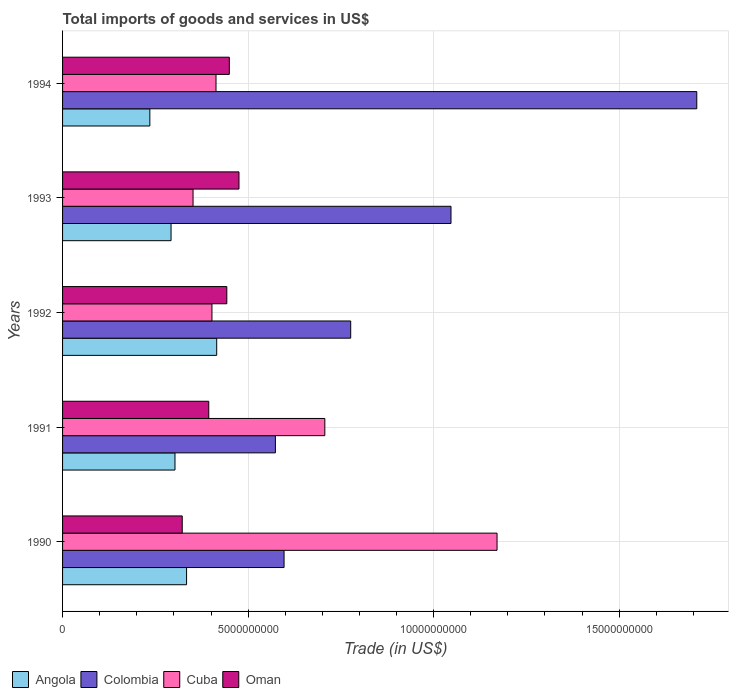How many groups of bars are there?
Provide a short and direct response. 5. Are the number of bars per tick equal to the number of legend labels?
Your answer should be compact. Yes. Are the number of bars on each tick of the Y-axis equal?
Offer a terse response. Yes. How many bars are there on the 2nd tick from the bottom?
Your answer should be very brief. 4. What is the total imports of goods and services in Cuba in 1992?
Make the answer very short. 4.03e+09. Across all years, what is the maximum total imports of goods and services in Angola?
Ensure brevity in your answer.  4.15e+09. Across all years, what is the minimum total imports of goods and services in Colombia?
Your response must be concise. 5.74e+09. In which year was the total imports of goods and services in Angola minimum?
Your response must be concise. 1994. What is the total total imports of goods and services in Cuba in the graph?
Provide a succinct answer. 3.05e+1. What is the difference between the total imports of goods and services in Oman in 1991 and that in 1993?
Provide a short and direct response. -8.14e+08. What is the difference between the total imports of goods and services in Colombia in 1994 and the total imports of goods and services in Angola in 1993?
Give a very brief answer. 1.42e+1. What is the average total imports of goods and services in Cuba per year?
Ensure brevity in your answer.  6.09e+09. In the year 1991, what is the difference between the total imports of goods and services in Cuba and total imports of goods and services in Oman?
Provide a succinct answer. 3.13e+09. What is the ratio of the total imports of goods and services in Cuba in 1991 to that in 1992?
Provide a succinct answer. 1.76. What is the difference between the highest and the second highest total imports of goods and services in Colombia?
Provide a succinct answer. 6.62e+09. What is the difference between the highest and the lowest total imports of goods and services in Angola?
Keep it short and to the point. 1.80e+09. In how many years, is the total imports of goods and services in Oman greater than the average total imports of goods and services in Oman taken over all years?
Your response must be concise. 3. Is it the case that in every year, the sum of the total imports of goods and services in Angola and total imports of goods and services in Colombia is greater than the sum of total imports of goods and services in Oman and total imports of goods and services in Cuba?
Your response must be concise. Yes. What does the 2nd bar from the top in 1992 represents?
Provide a succinct answer. Cuba. What does the 2nd bar from the bottom in 1994 represents?
Ensure brevity in your answer.  Colombia. How many bars are there?
Your answer should be compact. 20. Are all the bars in the graph horizontal?
Ensure brevity in your answer.  Yes. How many years are there in the graph?
Ensure brevity in your answer.  5. What is the difference between two consecutive major ticks on the X-axis?
Offer a very short reply. 5.00e+09. Are the values on the major ticks of X-axis written in scientific E-notation?
Offer a very short reply. No. Does the graph contain grids?
Offer a terse response. Yes. How many legend labels are there?
Your answer should be compact. 4. What is the title of the graph?
Your answer should be very brief. Total imports of goods and services in US$. What is the label or title of the X-axis?
Your response must be concise. Trade (in US$). What is the Trade (in US$) of Angola in 1990?
Ensure brevity in your answer.  3.34e+09. What is the Trade (in US$) in Colombia in 1990?
Provide a succinct answer. 5.97e+09. What is the Trade (in US$) in Cuba in 1990?
Give a very brief answer. 1.17e+1. What is the Trade (in US$) of Oman in 1990?
Ensure brevity in your answer.  3.22e+09. What is the Trade (in US$) of Angola in 1991?
Your answer should be very brief. 3.03e+09. What is the Trade (in US$) of Colombia in 1991?
Your answer should be compact. 5.74e+09. What is the Trade (in US$) in Cuba in 1991?
Ensure brevity in your answer.  7.07e+09. What is the Trade (in US$) in Oman in 1991?
Your answer should be compact. 3.94e+09. What is the Trade (in US$) in Angola in 1992?
Provide a succinct answer. 4.15e+09. What is the Trade (in US$) of Colombia in 1992?
Keep it short and to the point. 7.77e+09. What is the Trade (in US$) of Cuba in 1992?
Provide a succinct answer. 4.03e+09. What is the Trade (in US$) in Oman in 1992?
Your answer should be compact. 4.43e+09. What is the Trade (in US$) in Angola in 1993?
Your answer should be compact. 2.92e+09. What is the Trade (in US$) in Colombia in 1993?
Offer a terse response. 1.05e+1. What is the Trade (in US$) in Cuba in 1993?
Your answer should be very brief. 3.52e+09. What is the Trade (in US$) of Oman in 1993?
Offer a very short reply. 4.75e+09. What is the Trade (in US$) in Angola in 1994?
Offer a very short reply. 2.35e+09. What is the Trade (in US$) in Colombia in 1994?
Give a very brief answer. 1.71e+1. What is the Trade (in US$) of Cuba in 1994?
Make the answer very short. 4.14e+09. What is the Trade (in US$) of Oman in 1994?
Your answer should be very brief. 4.49e+09. Across all years, what is the maximum Trade (in US$) in Angola?
Your answer should be very brief. 4.15e+09. Across all years, what is the maximum Trade (in US$) in Colombia?
Your response must be concise. 1.71e+1. Across all years, what is the maximum Trade (in US$) of Cuba?
Make the answer very short. 1.17e+1. Across all years, what is the maximum Trade (in US$) in Oman?
Keep it short and to the point. 4.75e+09. Across all years, what is the minimum Trade (in US$) of Angola?
Make the answer very short. 2.35e+09. Across all years, what is the minimum Trade (in US$) of Colombia?
Give a very brief answer. 5.74e+09. Across all years, what is the minimum Trade (in US$) in Cuba?
Make the answer very short. 3.52e+09. Across all years, what is the minimum Trade (in US$) in Oman?
Provide a succinct answer. 3.22e+09. What is the total Trade (in US$) of Angola in the graph?
Offer a terse response. 1.58e+1. What is the total Trade (in US$) of Colombia in the graph?
Ensure brevity in your answer.  4.70e+1. What is the total Trade (in US$) in Cuba in the graph?
Your response must be concise. 3.05e+1. What is the total Trade (in US$) in Oman in the graph?
Offer a very short reply. 2.08e+1. What is the difference between the Trade (in US$) in Angola in 1990 and that in 1991?
Provide a short and direct response. 3.13e+08. What is the difference between the Trade (in US$) in Colombia in 1990 and that in 1991?
Ensure brevity in your answer.  2.33e+08. What is the difference between the Trade (in US$) of Cuba in 1990 and that in 1991?
Give a very brief answer. 4.64e+09. What is the difference between the Trade (in US$) of Oman in 1990 and that in 1991?
Provide a succinct answer. -7.15e+08. What is the difference between the Trade (in US$) of Angola in 1990 and that in 1992?
Your response must be concise. -8.12e+08. What is the difference between the Trade (in US$) in Colombia in 1990 and that in 1992?
Your response must be concise. -1.80e+09. What is the difference between the Trade (in US$) of Cuba in 1990 and that in 1992?
Your response must be concise. 7.68e+09. What is the difference between the Trade (in US$) of Oman in 1990 and that in 1992?
Give a very brief answer. -1.20e+09. What is the difference between the Trade (in US$) in Angola in 1990 and that in 1993?
Make the answer very short. 4.19e+08. What is the difference between the Trade (in US$) in Colombia in 1990 and that in 1993?
Your answer should be compact. -4.50e+09. What is the difference between the Trade (in US$) in Cuba in 1990 and that in 1993?
Give a very brief answer. 8.19e+09. What is the difference between the Trade (in US$) in Oman in 1990 and that in 1993?
Your response must be concise. -1.53e+09. What is the difference between the Trade (in US$) of Angola in 1990 and that in 1994?
Your answer should be very brief. 9.90e+08. What is the difference between the Trade (in US$) in Colombia in 1990 and that in 1994?
Give a very brief answer. -1.11e+1. What is the difference between the Trade (in US$) of Cuba in 1990 and that in 1994?
Your response must be concise. 7.57e+09. What is the difference between the Trade (in US$) in Oman in 1990 and that in 1994?
Ensure brevity in your answer.  -1.27e+09. What is the difference between the Trade (in US$) in Angola in 1991 and that in 1992?
Give a very brief answer. -1.12e+09. What is the difference between the Trade (in US$) in Colombia in 1991 and that in 1992?
Keep it short and to the point. -2.03e+09. What is the difference between the Trade (in US$) of Cuba in 1991 and that in 1992?
Keep it short and to the point. 3.04e+09. What is the difference between the Trade (in US$) of Oman in 1991 and that in 1992?
Make the answer very short. -4.86e+08. What is the difference between the Trade (in US$) of Angola in 1991 and that in 1993?
Provide a succinct answer. 1.06e+08. What is the difference between the Trade (in US$) of Colombia in 1991 and that in 1993?
Provide a short and direct response. -4.73e+09. What is the difference between the Trade (in US$) in Cuba in 1991 and that in 1993?
Ensure brevity in your answer.  3.55e+09. What is the difference between the Trade (in US$) in Oman in 1991 and that in 1993?
Ensure brevity in your answer.  -8.14e+08. What is the difference between the Trade (in US$) of Angola in 1991 and that in 1994?
Give a very brief answer. 6.78e+08. What is the difference between the Trade (in US$) in Colombia in 1991 and that in 1994?
Give a very brief answer. -1.14e+1. What is the difference between the Trade (in US$) of Cuba in 1991 and that in 1994?
Ensure brevity in your answer.  2.93e+09. What is the difference between the Trade (in US$) in Oman in 1991 and that in 1994?
Provide a short and direct response. -5.54e+08. What is the difference between the Trade (in US$) in Angola in 1992 and that in 1993?
Your response must be concise. 1.23e+09. What is the difference between the Trade (in US$) in Colombia in 1992 and that in 1993?
Offer a terse response. -2.70e+09. What is the difference between the Trade (in US$) of Cuba in 1992 and that in 1993?
Ensure brevity in your answer.  5.09e+08. What is the difference between the Trade (in US$) in Oman in 1992 and that in 1993?
Your answer should be compact. -3.28e+08. What is the difference between the Trade (in US$) of Angola in 1992 and that in 1994?
Your answer should be very brief. 1.80e+09. What is the difference between the Trade (in US$) in Colombia in 1992 and that in 1994?
Provide a succinct answer. -9.33e+09. What is the difference between the Trade (in US$) of Cuba in 1992 and that in 1994?
Your answer should be very brief. -1.09e+08. What is the difference between the Trade (in US$) in Oman in 1992 and that in 1994?
Your answer should be very brief. -6.76e+07. What is the difference between the Trade (in US$) of Angola in 1993 and that in 1994?
Provide a short and direct response. 5.72e+08. What is the difference between the Trade (in US$) in Colombia in 1993 and that in 1994?
Give a very brief answer. -6.62e+09. What is the difference between the Trade (in US$) in Cuba in 1993 and that in 1994?
Your response must be concise. -6.19e+08. What is the difference between the Trade (in US$) in Oman in 1993 and that in 1994?
Your response must be concise. 2.60e+08. What is the difference between the Trade (in US$) of Angola in 1990 and the Trade (in US$) of Colombia in 1991?
Your response must be concise. -2.39e+09. What is the difference between the Trade (in US$) in Angola in 1990 and the Trade (in US$) in Cuba in 1991?
Your answer should be very brief. -3.73e+09. What is the difference between the Trade (in US$) in Angola in 1990 and the Trade (in US$) in Oman in 1991?
Your answer should be very brief. -5.98e+08. What is the difference between the Trade (in US$) in Colombia in 1990 and the Trade (in US$) in Cuba in 1991?
Offer a very short reply. -1.10e+09. What is the difference between the Trade (in US$) of Colombia in 1990 and the Trade (in US$) of Oman in 1991?
Provide a succinct answer. 2.03e+09. What is the difference between the Trade (in US$) in Cuba in 1990 and the Trade (in US$) in Oman in 1991?
Your response must be concise. 7.77e+09. What is the difference between the Trade (in US$) of Angola in 1990 and the Trade (in US$) of Colombia in 1992?
Your response must be concise. -4.42e+09. What is the difference between the Trade (in US$) in Angola in 1990 and the Trade (in US$) in Cuba in 1992?
Offer a very short reply. -6.84e+08. What is the difference between the Trade (in US$) in Angola in 1990 and the Trade (in US$) in Oman in 1992?
Give a very brief answer. -1.08e+09. What is the difference between the Trade (in US$) of Colombia in 1990 and the Trade (in US$) of Cuba in 1992?
Offer a terse response. 1.94e+09. What is the difference between the Trade (in US$) of Colombia in 1990 and the Trade (in US$) of Oman in 1992?
Your answer should be compact. 1.54e+09. What is the difference between the Trade (in US$) in Cuba in 1990 and the Trade (in US$) in Oman in 1992?
Offer a very short reply. 7.28e+09. What is the difference between the Trade (in US$) of Angola in 1990 and the Trade (in US$) of Colombia in 1993?
Your answer should be compact. -7.13e+09. What is the difference between the Trade (in US$) of Angola in 1990 and the Trade (in US$) of Cuba in 1993?
Your response must be concise. -1.74e+08. What is the difference between the Trade (in US$) in Angola in 1990 and the Trade (in US$) in Oman in 1993?
Your answer should be compact. -1.41e+09. What is the difference between the Trade (in US$) in Colombia in 1990 and the Trade (in US$) in Cuba in 1993?
Provide a succinct answer. 2.45e+09. What is the difference between the Trade (in US$) in Colombia in 1990 and the Trade (in US$) in Oman in 1993?
Give a very brief answer. 1.21e+09. What is the difference between the Trade (in US$) of Cuba in 1990 and the Trade (in US$) of Oman in 1993?
Your response must be concise. 6.95e+09. What is the difference between the Trade (in US$) in Angola in 1990 and the Trade (in US$) in Colombia in 1994?
Offer a terse response. -1.37e+1. What is the difference between the Trade (in US$) in Angola in 1990 and the Trade (in US$) in Cuba in 1994?
Your answer should be compact. -7.93e+08. What is the difference between the Trade (in US$) of Angola in 1990 and the Trade (in US$) of Oman in 1994?
Make the answer very short. -1.15e+09. What is the difference between the Trade (in US$) in Colombia in 1990 and the Trade (in US$) in Cuba in 1994?
Give a very brief answer. 1.83e+09. What is the difference between the Trade (in US$) of Colombia in 1990 and the Trade (in US$) of Oman in 1994?
Your answer should be very brief. 1.47e+09. What is the difference between the Trade (in US$) in Cuba in 1990 and the Trade (in US$) in Oman in 1994?
Your answer should be compact. 7.21e+09. What is the difference between the Trade (in US$) in Angola in 1991 and the Trade (in US$) in Colombia in 1992?
Provide a succinct answer. -4.74e+09. What is the difference between the Trade (in US$) in Angola in 1991 and the Trade (in US$) in Cuba in 1992?
Keep it short and to the point. -9.96e+08. What is the difference between the Trade (in US$) of Angola in 1991 and the Trade (in US$) of Oman in 1992?
Provide a short and direct response. -1.40e+09. What is the difference between the Trade (in US$) in Colombia in 1991 and the Trade (in US$) in Cuba in 1992?
Make the answer very short. 1.71e+09. What is the difference between the Trade (in US$) of Colombia in 1991 and the Trade (in US$) of Oman in 1992?
Provide a succinct answer. 1.31e+09. What is the difference between the Trade (in US$) of Cuba in 1991 and the Trade (in US$) of Oman in 1992?
Offer a terse response. 2.64e+09. What is the difference between the Trade (in US$) in Angola in 1991 and the Trade (in US$) in Colombia in 1993?
Offer a terse response. -7.44e+09. What is the difference between the Trade (in US$) of Angola in 1991 and the Trade (in US$) of Cuba in 1993?
Offer a very short reply. -4.87e+08. What is the difference between the Trade (in US$) of Angola in 1991 and the Trade (in US$) of Oman in 1993?
Keep it short and to the point. -1.72e+09. What is the difference between the Trade (in US$) in Colombia in 1991 and the Trade (in US$) in Cuba in 1993?
Offer a very short reply. 2.22e+09. What is the difference between the Trade (in US$) in Colombia in 1991 and the Trade (in US$) in Oman in 1993?
Your response must be concise. 9.81e+08. What is the difference between the Trade (in US$) of Cuba in 1991 and the Trade (in US$) of Oman in 1993?
Your answer should be compact. 2.31e+09. What is the difference between the Trade (in US$) of Angola in 1991 and the Trade (in US$) of Colombia in 1994?
Provide a short and direct response. -1.41e+1. What is the difference between the Trade (in US$) of Angola in 1991 and the Trade (in US$) of Cuba in 1994?
Make the answer very short. -1.11e+09. What is the difference between the Trade (in US$) of Angola in 1991 and the Trade (in US$) of Oman in 1994?
Provide a succinct answer. -1.46e+09. What is the difference between the Trade (in US$) in Colombia in 1991 and the Trade (in US$) in Cuba in 1994?
Ensure brevity in your answer.  1.60e+09. What is the difference between the Trade (in US$) of Colombia in 1991 and the Trade (in US$) of Oman in 1994?
Your answer should be compact. 1.24e+09. What is the difference between the Trade (in US$) in Cuba in 1991 and the Trade (in US$) in Oman in 1994?
Your answer should be very brief. 2.57e+09. What is the difference between the Trade (in US$) in Angola in 1992 and the Trade (in US$) in Colombia in 1993?
Your answer should be compact. -6.31e+09. What is the difference between the Trade (in US$) in Angola in 1992 and the Trade (in US$) in Cuba in 1993?
Give a very brief answer. 6.37e+08. What is the difference between the Trade (in US$) in Angola in 1992 and the Trade (in US$) in Oman in 1993?
Ensure brevity in your answer.  -6.00e+08. What is the difference between the Trade (in US$) of Colombia in 1992 and the Trade (in US$) of Cuba in 1993?
Offer a terse response. 4.25e+09. What is the difference between the Trade (in US$) of Colombia in 1992 and the Trade (in US$) of Oman in 1993?
Give a very brief answer. 3.01e+09. What is the difference between the Trade (in US$) of Cuba in 1992 and the Trade (in US$) of Oman in 1993?
Your response must be concise. -7.28e+08. What is the difference between the Trade (in US$) of Angola in 1992 and the Trade (in US$) of Colombia in 1994?
Your answer should be very brief. -1.29e+1. What is the difference between the Trade (in US$) of Angola in 1992 and the Trade (in US$) of Cuba in 1994?
Ensure brevity in your answer.  1.86e+07. What is the difference between the Trade (in US$) in Angola in 1992 and the Trade (in US$) in Oman in 1994?
Provide a succinct answer. -3.40e+08. What is the difference between the Trade (in US$) in Colombia in 1992 and the Trade (in US$) in Cuba in 1994?
Give a very brief answer. 3.63e+09. What is the difference between the Trade (in US$) of Colombia in 1992 and the Trade (in US$) of Oman in 1994?
Provide a short and direct response. 3.27e+09. What is the difference between the Trade (in US$) in Cuba in 1992 and the Trade (in US$) in Oman in 1994?
Offer a terse response. -4.68e+08. What is the difference between the Trade (in US$) in Angola in 1993 and the Trade (in US$) in Colombia in 1994?
Offer a terse response. -1.42e+1. What is the difference between the Trade (in US$) of Angola in 1993 and the Trade (in US$) of Cuba in 1994?
Keep it short and to the point. -1.21e+09. What is the difference between the Trade (in US$) of Angola in 1993 and the Trade (in US$) of Oman in 1994?
Your answer should be compact. -1.57e+09. What is the difference between the Trade (in US$) of Colombia in 1993 and the Trade (in US$) of Cuba in 1994?
Your answer should be compact. 6.33e+09. What is the difference between the Trade (in US$) of Colombia in 1993 and the Trade (in US$) of Oman in 1994?
Keep it short and to the point. 5.97e+09. What is the difference between the Trade (in US$) in Cuba in 1993 and the Trade (in US$) in Oman in 1994?
Make the answer very short. -9.78e+08. What is the average Trade (in US$) of Angola per year?
Make the answer very short. 3.16e+09. What is the average Trade (in US$) in Colombia per year?
Your answer should be compact. 9.41e+09. What is the average Trade (in US$) in Cuba per year?
Provide a short and direct response. 6.09e+09. What is the average Trade (in US$) in Oman per year?
Give a very brief answer. 4.17e+09. In the year 1990, what is the difference between the Trade (in US$) of Angola and Trade (in US$) of Colombia?
Your answer should be very brief. -2.63e+09. In the year 1990, what is the difference between the Trade (in US$) in Angola and Trade (in US$) in Cuba?
Provide a short and direct response. -8.37e+09. In the year 1990, what is the difference between the Trade (in US$) in Angola and Trade (in US$) in Oman?
Provide a succinct answer. 1.17e+08. In the year 1990, what is the difference between the Trade (in US$) in Colombia and Trade (in US$) in Cuba?
Make the answer very short. -5.74e+09. In the year 1990, what is the difference between the Trade (in US$) in Colombia and Trade (in US$) in Oman?
Provide a succinct answer. 2.74e+09. In the year 1990, what is the difference between the Trade (in US$) in Cuba and Trade (in US$) in Oman?
Your answer should be compact. 8.48e+09. In the year 1991, what is the difference between the Trade (in US$) of Angola and Trade (in US$) of Colombia?
Your answer should be very brief. -2.71e+09. In the year 1991, what is the difference between the Trade (in US$) in Angola and Trade (in US$) in Cuba?
Provide a short and direct response. -4.04e+09. In the year 1991, what is the difference between the Trade (in US$) of Angola and Trade (in US$) of Oman?
Your answer should be very brief. -9.11e+08. In the year 1991, what is the difference between the Trade (in US$) in Colombia and Trade (in US$) in Cuba?
Provide a short and direct response. -1.33e+09. In the year 1991, what is the difference between the Trade (in US$) in Colombia and Trade (in US$) in Oman?
Offer a terse response. 1.80e+09. In the year 1991, what is the difference between the Trade (in US$) in Cuba and Trade (in US$) in Oman?
Your answer should be very brief. 3.13e+09. In the year 1992, what is the difference between the Trade (in US$) of Angola and Trade (in US$) of Colombia?
Make the answer very short. -3.61e+09. In the year 1992, what is the difference between the Trade (in US$) of Angola and Trade (in US$) of Cuba?
Your answer should be very brief. 1.28e+08. In the year 1992, what is the difference between the Trade (in US$) in Angola and Trade (in US$) in Oman?
Your answer should be compact. -2.73e+08. In the year 1992, what is the difference between the Trade (in US$) in Colombia and Trade (in US$) in Cuba?
Ensure brevity in your answer.  3.74e+09. In the year 1992, what is the difference between the Trade (in US$) in Colombia and Trade (in US$) in Oman?
Your response must be concise. 3.34e+09. In the year 1992, what is the difference between the Trade (in US$) of Cuba and Trade (in US$) of Oman?
Keep it short and to the point. -4.01e+08. In the year 1993, what is the difference between the Trade (in US$) in Angola and Trade (in US$) in Colombia?
Your response must be concise. -7.54e+09. In the year 1993, what is the difference between the Trade (in US$) in Angola and Trade (in US$) in Cuba?
Offer a very short reply. -5.93e+08. In the year 1993, what is the difference between the Trade (in US$) of Angola and Trade (in US$) of Oman?
Provide a short and direct response. -1.83e+09. In the year 1993, what is the difference between the Trade (in US$) of Colombia and Trade (in US$) of Cuba?
Keep it short and to the point. 6.95e+09. In the year 1993, what is the difference between the Trade (in US$) of Colombia and Trade (in US$) of Oman?
Your response must be concise. 5.71e+09. In the year 1993, what is the difference between the Trade (in US$) of Cuba and Trade (in US$) of Oman?
Provide a short and direct response. -1.24e+09. In the year 1994, what is the difference between the Trade (in US$) of Angola and Trade (in US$) of Colombia?
Your response must be concise. -1.47e+1. In the year 1994, what is the difference between the Trade (in US$) in Angola and Trade (in US$) in Cuba?
Offer a very short reply. -1.78e+09. In the year 1994, what is the difference between the Trade (in US$) of Angola and Trade (in US$) of Oman?
Make the answer very short. -2.14e+09. In the year 1994, what is the difference between the Trade (in US$) in Colombia and Trade (in US$) in Cuba?
Your answer should be compact. 1.30e+1. In the year 1994, what is the difference between the Trade (in US$) in Colombia and Trade (in US$) in Oman?
Provide a succinct answer. 1.26e+1. In the year 1994, what is the difference between the Trade (in US$) in Cuba and Trade (in US$) in Oman?
Your answer should be very brief. -3.59e+08. What is the ratio of the Trade (in US$) in Angola in 1990 to that in 1991?
Offer a terse response. 1.1. What is the ratio of the Trade (in US$) in Colombia in 1990 to that in 1991?
Your response must be concise. 1.04. What is the ratio of the Trade (in US$) of Cuba in 1990 to that in 1991?
Offer a very short reply. 1.66. What is the ratio of the Trade (in US$) of Oman in 1990 to that in 1991?
Keep it short and to the point. 0.82. What is the ratio of the Trade (in US$) in Angola in 1990 to that in 1992?
Keep it short and to the point. 0.8. What is the ratio of the Trade (in US$) of Colombia in 1990 to that in 1992?
Provide a succinct answer. 0.77. What is the ratio of the Trade (in US$) of Cuba in 1990 to that in 1992?
Your answer should be very brief. 2.91. What is the ratio of the Trade (in US$) of Oman in 1990 to that in 1992?
Keep it short and to the point. 0.73. What is the ratio of the Trade (in US$) of Angola in 1990 to that in 1993?
Keep it short and to the point. 1.14. What is the ratio of the Trade (in US$) of Colombia in 1990 to that in 1993?
Provide a short and direct response. 0.57. What is the ratio of the Trade (in US$) of Cuba in 1990 to that in 1993?
Make the answer very short. 3.33. What is the ratio of the Trade (in US$) in Oman in 1990 to that in 1993?
Give a very brief answer. 0.68. What is the ratio of the Trade (in US$) of Angola in 1990 to that in 1994?
Keep it short and to the point. 1.42. What is the ratio of the Trade (in US$) of Colombia in 1990 to that in 1994?
Your answer should be very brief. 0.35. What is the ratio of the Trade (in US$) of Cuba in 1990 to that in 1994?
Keep it short and to the point. 2.83. What is the ratio of the Trade (in US$) of Oman in 1990 to that in 1994?
Give a very brief answer. 0.72. What is the ratio of the Trade (in US$) in Angola in 1991 to that in 1992?
Keep it short and to the point. 0.73. What is the ratio of the Trade (in US$) in Colombia in 1991 to that in 1992?
Your answer should be very brief. 0.74. What is the ratio of the Trade (in US$) of Cuba in 1991 to that in 1992?
Offer a terse response. 1.76. What is the ratio of the Trade (in US$) in Oman in 1991 to that in 1992?
Your answer should be compact. 0.89. What is the ratio of the Trade (in US$) of Angola in 1991 to that in 1993?
Your response must be concise. 1.04. What is the ratio of the Trade (in US$) of Colombia in 1991 to that in 1993?
Provide a succinct answer. 0.55. What is the ratio of the Trade (in US$) in Cuba in 1991 to that in 1993?
Provide a short and direct response. 2.01. What is the ratio of the Trade (in US$) of Oman in 1991 to that in 1993?
Ensure brevity in your answer.  0.83. What is the ratio of the Trade (in US$) of Angola in 1991 to that in 1994?
Make the answer very short. 1.29. What is the ratio of the Trade (in US$) of Colombia in 1991 to that in 1994?
Offer a terse response. 0.34. What is the ratio of the Trade (in US$) of Cuba in 1991 to that in 1994?
Your answer should be very brief. 1.71. What is the ratio of the Trade (in US$) of Oman in 1991 to that in 1994?
Ensure brevity in your answer.  0.88. What is the ratio of the Trade (in US$) of Angola in 1992 to that in 1993?
Make the answer very short. 1.42. What is the ratio of the Trade (in US$) of Colombia in 1992 to that in 1993?
Your answer should be very brief. 0.74. What is the ratio of the Trade (in US$) of Cuba in 1992 to that in 1993?
Make the answer very short. 1.14. What is the ratio of the Trade (in US$) in Oman in 1992 to that in 1993?
Provide a short and direct response. 0.93. What is the ratio of the Trade (in US$) of Angola in 1992 to that in 1994?
Provide a succinct answer. 1.77. What is the ratio of the Trade (in US$) of Colombia in 1992 to that in 1994?
Ensure brevity in your answer.  0.45. What is the ratio of the Trade (in US$) of Cuba in 1992 to that in 1994?
Your response must be concise. 0.97. What is the ratio of the Trade (in US$) in Angola in 1993 to that in 1994?
Provide a succinct answer. 1.24. What is the ratio of the Trade (in US$) of Colombia in 1993 to that in 1994?
Keep it short and to the point. 0.61. What is the ratio of the Trade (in US$) in Cuba in 1993 to that in 1994?
Your answer should be compact. 0.85. What is the ratio of the Trade (in US$) of Oman in 1993 to that in 1994?
Offer a terse response. 1.06. What is the difference between the highest and the second highest Trade (in US$) of Angola?
Your answer should be compact. 8.12e+08. What is the difference between the highest and the second highest Trade (in US$) in Colombia?
Give a very brief answer. 6.62e+09. What is the difference between the highest and the second highest Trade (in US$) of Cuba?
Ensure brevity in your answer.  4.64e+09. What is the difference between the highest and the second highest Trade (in US$) in Oman?
Your answer should be compact. 2.60e+08. What is the difference between the highest and the lowest Trade (in US$) of Angola?
Give a very brief answer. 1.80e+09. What is the difference between the highest and the lowest Trade (in US$) of Colombia?
Give a very brief answer. 1.14e+1. What is the difference between the highest and the lowest Trade (in US$) in Cuba?
Offer a very short reply. 8.19e+09. What is the difference between the highest and the lowest Trade (in US$) of Oman?
Your answer should be compact. 1.53e+09. 